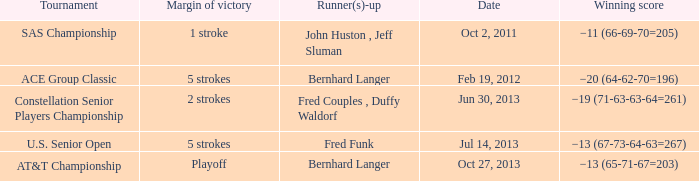Which Margin of victory has a Tournament of u.s. senior open? 5 strokes. 